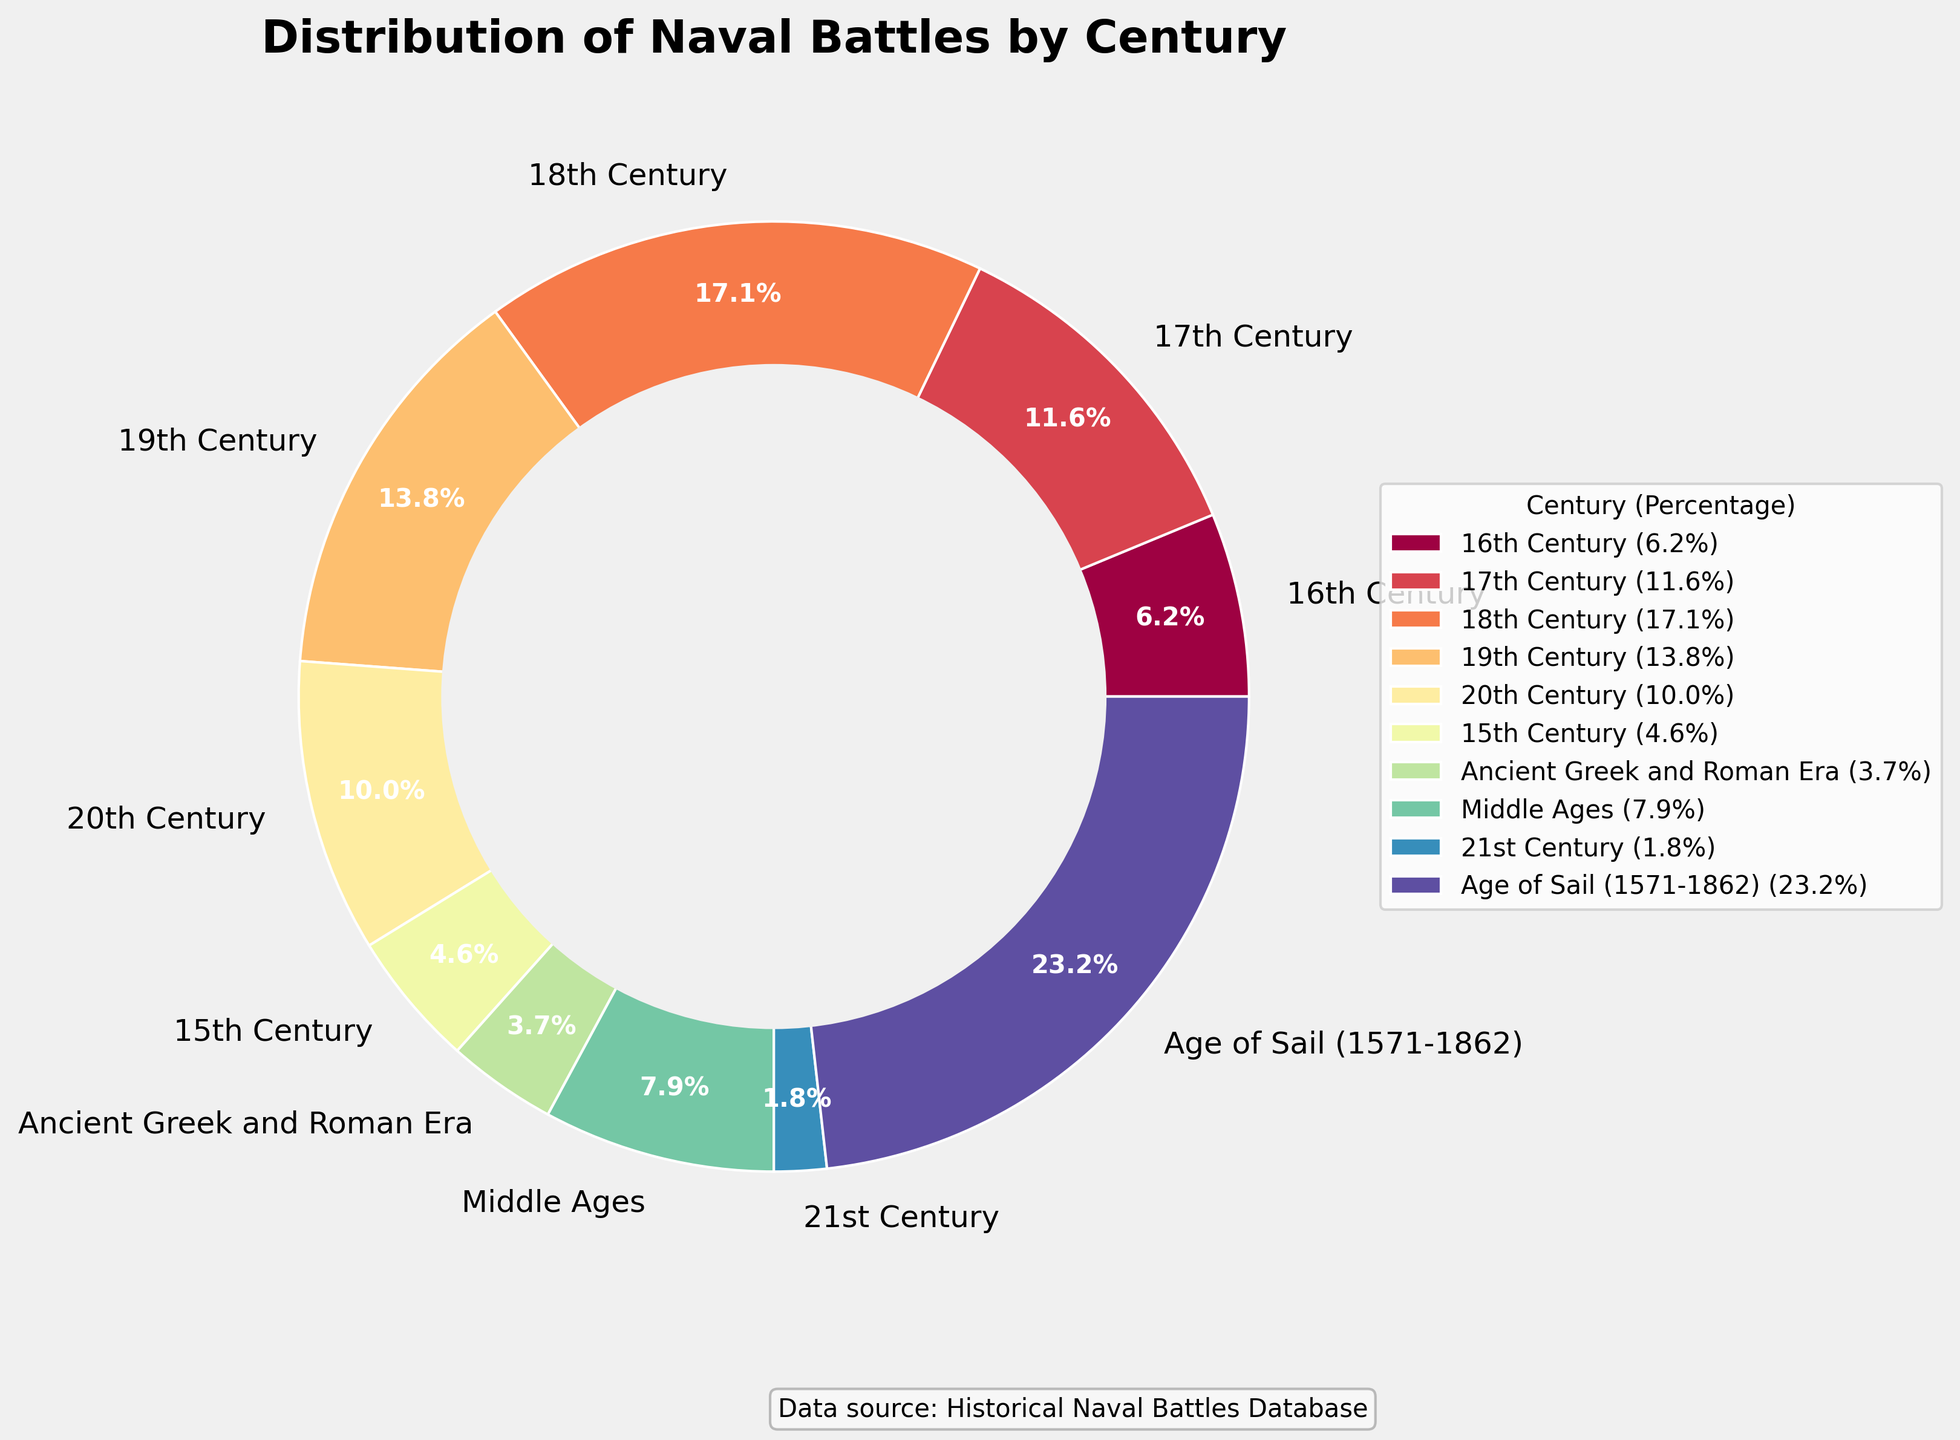What time period saw the highest percentage of naval battles? To determine the time period with the highest percentage of naval battles, look for the segment with the largest proportion. The Age of Sail has the largest segment labeled with 21.1%.
Answer: Age of Sail (21.1%) Which century had more naval battles: the 17th or the 20th century? To compare these centuries, look at their respective percentages. The 17th century has 10.6% while the 20th century has 9.1%. Thus, the 17th century had more naval battles.
Answer: 17th century Among the 15th, 16th, and 17th centuries, which had the fewest naval battles? Compare the percentages for these centuries: the 15th (4.2%), 16th (5.6%), and 17th (10.6%) centuries. The 15th century has the smallest percentage.
Answer: 15th century What is the combined percentage of naval battles that occurred during the Ancient Greek and Roman Era and the Middle Ages? Add the percentages for the Ancient Greek and Roman Era (3.3%) and the Middle Ages (7.0%). This totals 10.3%.
Answer: 10.3% Visually, which era or century has a color closest to dark red? Look at the segments' colors and find the one that appears dark red. The Age of Sail segment is closest to dark red, based on the color scheme used.
Answer: Age of Sail How many naval battles in total occurred in the 19th and 20th centuries? Add the number of naval battles from the 19th (93) and 20th centuries (67). Thus, the total is 93 + 67 = 160.
Answer: 160 Is the number of naval battles in the 18th century greater than the combined number from the Middle Ages and 21st century? Compare the number of naval battles in the 18th century (115) with the sum from the Middle Ages (53) and the 21st century (12). The sum is 53 + 12 = 65. Since 115 > 65, the 18th century has more battles.
Answer: Yes Which era or century had fewer naval battles than the 16th century but more than the 15th century? Identify which has fewer battles than the 16th century (42) but more than the 15th century (31). The Middle Ages had 53 battles, fitting this criteria.
Answer: Middle Ages What's the average number of naval battles for the 16th, 17th, and 18th centuries combined? First, sum the numbers: 42 (16th) + 78 (17th) + 115 (18th) = 235. Then, divide by the number of centuries (3). The average is 235 / 3 = 78.3.
Answer: 78.3 